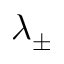<formula> <loc_0><loc_0><loc_500><loc_500>\lambda _ { \pm }</formula> 